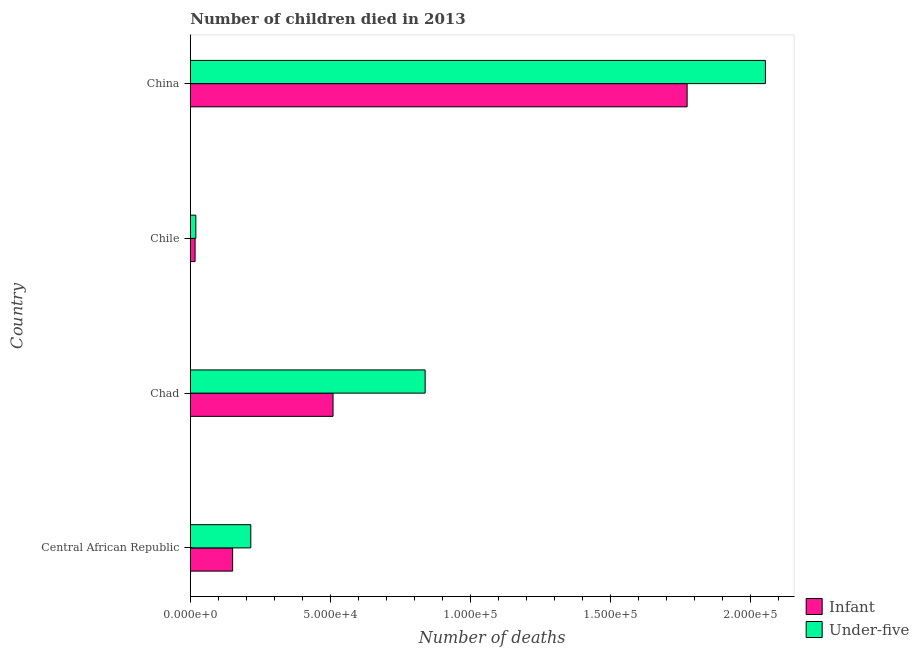How many groups of bars are there?
Your answer should be very brief. 4. Are the number of bars per tick equal to the number of legend labels?
Give a very brief answer. Yes. What is the label of the 2nd group of bars from the top?
Keep it short and to the point. Chile. In how many cases, is the number of bars for a given country not equal to the number of legend labels?
Make the answer very short. 0. What is the number of under-five deaths in Chile?
Your response must be concise. 1979. Across all countries, what is the maximum number of under-five deaths?
Your answer should be compact. 2.05e+05. Across all countries, what is the minimum number of infant deaths?
Your answer should be compact. 1717. In which country was the number of under-five deaths maximum?
Make the answer very short. China. In which country was the number of under-five deaths minimum?
Your answer should be compact. Chile. What is the total number of under-five deaths in the graph?
Offer a very short reply. 3.13e+05. What is the difference between the number of under-five deaths in Chad and that in China?
Give a very brief answer. -1.22e+05. What is the difference between the number of under-five deaths in Chad and the number of infant deaths in Chile?
Provide a short and direct response. 8.22e+04. What is the average number of under-five deaths per country?
Offer a terse response. 7.82e+04. What is the difference between the number of infant deaths and number of under-five deaths in Chile?
Make the answer very short. -262. What is the ratio of the number of infant deaths in Central African Republic to that in Chad?
Keep it short and to the point. 0.3. Is the number of under-five deaths in Chad less than that in Chile?
Your answer should be very brief. No. What is the difference between the highest and the second highest number of infant deaths?
Offer a very short reply. 1.27e+05. What is the difference between the highest and the lowest number of under-five deaths?
Give a very brief answer. 2.03e+05. What does the 1st bar from the top in Central African Republic represents?
Provide a short and direct response. Under-five. What does the 2nd bar from the bottom in China represents?
Give a very brief answer. Under-five. What is the difference between two consecutive major ticks on the X-axis?
Make the answer very short. 5.00e+04. Are the values on the major ticks of X-axis written in scientific E-notation?
Give a very brief answer. Yes. Does the graph contain grids?
Provide a short and direct response. No. How are the legend labels stacked?
Provide a short and direct response. Vertical. What is the title of the graph?
Make the answer very short. Number of children died in 2013. Does "Crop" appear as one of the legend labels in the graph?
Your answer should be compact. No. What is the label or title of the X-axis?
Provide a succinct answer. Number of deaths. What is the label or title of the Y-axis?
Your response must be concise. Country. What is the Number of deaths of Infant in Central African Republic?
Give a very brief answer. 1.51e+04. What is the Number of deaths in Under-five in Central African Republic?
Ensure brevity in your answer.  2.16e+04. What is the Number of deaths of Infant in Chad?
Your response must be concise. 5.10e+04. What is the Number of deaths in Under-five in Chad?
Keep it short and to the point. 8.39e+04. What is the Number of deaths in Infant in Chile?
Ensure brevity in your answer.  1717. What is the Number of deaths of Under-five in Chile?
Offer a terse response. 1979. What is the Number of deaths of Infant in China?
Provide a succinct answer. 1.78e+05. What is the Number of deaths in Under-five in China?
Give a very brief answer. 2.05e+05. Across all countries, what is the maximum Number of deaths in Infant?
Your answer should be compact. 1.78e+05. Across all countries, what is the maximum Number of deaths of Under-five?
Keep it short and to the point. 2.05e+05. Across all countries, what is the minimum Number of deaths of Infant?
Ensure brevity in your answer.  1717. Across all countries, what is the minimum Number of deaths in Under-five?
Provide a short and direct response. 1979. What is the total Number of deaths of Infant in the graph?
Provide a succinct answer. 2.45e+05. What is the total Number of deaths in Under-five in the graph?
Ensure brevity in your answer.  3.13e+05. What is the difference between the Number of deaths of Infant in Central African Republic and that in Chad?
Your answer should be compact. -3.59e+04. What is the difference between the Number of deaths of Under-five in Central African Republic and that in Chad?
Offer a terse response. -6.23e+04. What is the difference between the Number of deaths in Infant in Central African Republic and that in Chile?
Give a very brief answer. 1.34e+04. What is the difference between the Number of deaths in Under-five in Central African Republic and that in Chile?
Offer a terse response. 1.96e+04. What is the difference between the Number of deaths of Infant in Central African Republic and that in China?
Ensure brevity in your answer.  -1.62e+05. What is the difference between the Number of deaths of Under-five in Central African Republic and that in China?
Provide a short and direct response. -1.84e+05. What is the difference between the Number of deaths of Infant in Chad and that in Chile?
Give a very brief answer. 4.93e+04. What is the difference between the Number of deaths of Under-five in Chad and that in Chile?
Your answer should be very brief. 8.19e+04. What is the difference between the Number of deaths in Infant in Chad and that in China?
Give a very brief answer. -1.27e+05. What is the difference between the Number of deaths of Under-five in Chad and that in China?
Offer a terse response. -1.22e+05. What is the difference between the Number of deaths of Infant in Chile and that in China?
Your response must be concise. -1.76e+05. What is the difference between the Number of deaths of Under-five in Chile and that in China?
Offer a very short reply. -2.03e+05. What is the difference between the Number of deaths in Infant in Central African Republic and the Number of deaths in Under-five in Chad?
Provide a succinct answer. -6.88e+04. What is the difference between the Number of deaths of Infant in Central African Republic and the Number of deaths of Under-five in Chile?
Make the answer very short. 1.31e+04. What is the difference between the Number of deaths in Infant in Central African Republic and the Number of deaths in Under-five in China?
Give a very brief answer. -1.90e+05. What is the difference between the Number of deaths in Infant in Chad and the Number of deaths in Under-five in Chile?
Your answer should be compact. 4.90e+04. What is the difference between the Number of deaths of Infant in Chad and the Number of deaths of Under-five in China?
Your response must be concise. -1.54e+05. What is the difference between the Number of deaths of Infant in Chile and the Number of deaths of Under-five in China?
Provide a succinct answer. -2.04e+05. What is the average Number of deaths of Infant per country?
Provide a succinct answer. 6.13e+04. What is the average Number of deaths in Under-five per country?
Offer a terse response. 7.82e+04. What is the difference between the Number of deaths of Infant and Number of deaths of Under-five in Central African Republic?
Your answer should be compact. -6488. What is the difference between the Number of deaths in Infant and Number of deaths in Under-five in Chad?
Provide a short and direct response. -3.29e+04. What is the difference between the Number of deaths of Infant and Number of deaths of Under-five in Chile?
Your answer should be compact. -262. What is the difference between the Number of deaths of Infant and Number of deaths of Under-five in China?
Give a very brief answer. -2.80e+04. What is the ratio of the Number of deaths of Infant in Central African Republic to that in Chad?
Your response must be concise. 0.3. What is the ratio of the Number of deaths of Under-five in Central African Republic to that in Chad?
Offer a very short reply. 0.26. What is the ratio of the Number of deaths of Infant in Central African Republic to that in Chile?
Your answer should be compact. 8.81. What is the ratio of the Number of deaths of Under-five in Central African Republic to that in Chile?
Offer a terse response. 10.92. What is the ratio of the Number of deaths in Infant in Central African Republic to that in China?
Your answer should be compact. 0.09. What is the ratio of the Number of deaths of Under-five in Central African Republic to that in China?
Provide a short and direct response. 0.11. What is the ratio of the Number of deaths of Infant in Chad to that in Chile?
Offer a very short reply. 29.7. What is the ratio of the Number of deaths of Under-five in Chad to that in Chile?
Your answer should be compact. 42.4. What is the ratio of the Number of deaths of Infant in Chad to that in China?
Your answer should be very brief. 0.29. What is the ratio of the Number of deaths of Under-five in Chad to that in China?
Ensure brevity in your answer.  0.41. What is the ratio of the Number of deaths in Infant in Chile to that in China?
Your answer should be compact. 0.01. What is the ratio of the Number of deaths of Under-five in Chile to that in China?
Make the answer very short. 0.01. What is the difference between the highest and the second highest Number of deaths in Infant?
Provide a succinct answer. 1.27e+05. What is the difference between the highest and the second highest Number of deaths in Under-five?
Make the answer very short. 1.22e+05. What is the difference between the highest and the lowest Number of deaths in Infant?
Your response must be concise. 1.76e+05. What is the difference between the highest and the lowest Number of deaths in Under-five?
Give a very brief answer. 2.03e+05. 